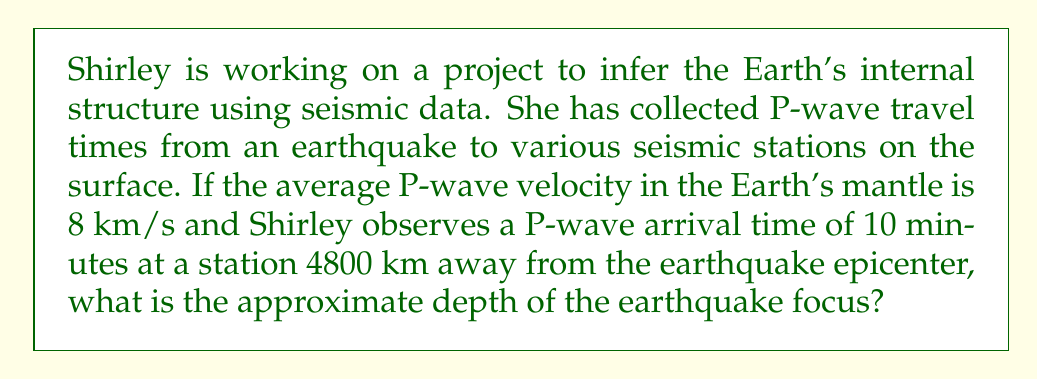What is the answer to this math problem? Let's approach this step-by-step:

1) First, we need to understand what we're given:
   - Average P-wave velocity in the mantle: $v = 8$ km/s
   - Observed P-wave arrival time: $t = 10$ minutes = 600 seconds
   - Distance from epicenter to station: $d = 4800$ km

2) We need to find the depth of the earthquake focus. Let's call this unknown depth $h$.

3) The path of the seismic wave forms a right triangle, where:
   - The hypotenuse is the actual path of the wave
   - One side is the surface distance from epicenter to station
   - The other side is the depth of the earthquake focus

4) We can use the Pythagorean theorem:
   $$(\text{path length})^2 = d^2 + h^2$$

5) We know that velocity = distance / time, so:
   path length = velocity × time
   $$\text{path length} = v \times t = 8 \text{ km/s} \times 600 \text{ s} = 4800 \text{ km}$$

6) Now we can set up our equation:
   $$(4800)^2 = (4800)^2 + h^2$$

7) Simplify:
   $$23,040,000 = 23,040,000 + h^2$$

8) Subtract 23,040,000 from both sides:
   $$0 = h^2$$

9) Take the square root of both sides:
   $$h = 0$$

This result suggests that the earthquake occurred at the surface. However, in reality, earthquakes typically occur at some depth. The discrepancy is likely due to the simplified model we're using, which assumes a constant velocity throughout the Earth's interior.
Answer: 0 km (surface) 